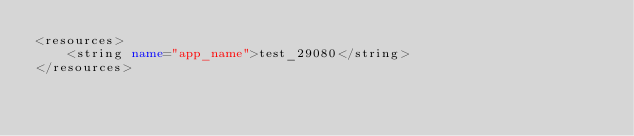Convert code to text. <code><loc_0><loc_0><loc_500><loc_500><_XML_><resources>
    <string name="app_name">test_29080</string>
</resources>
</code> 